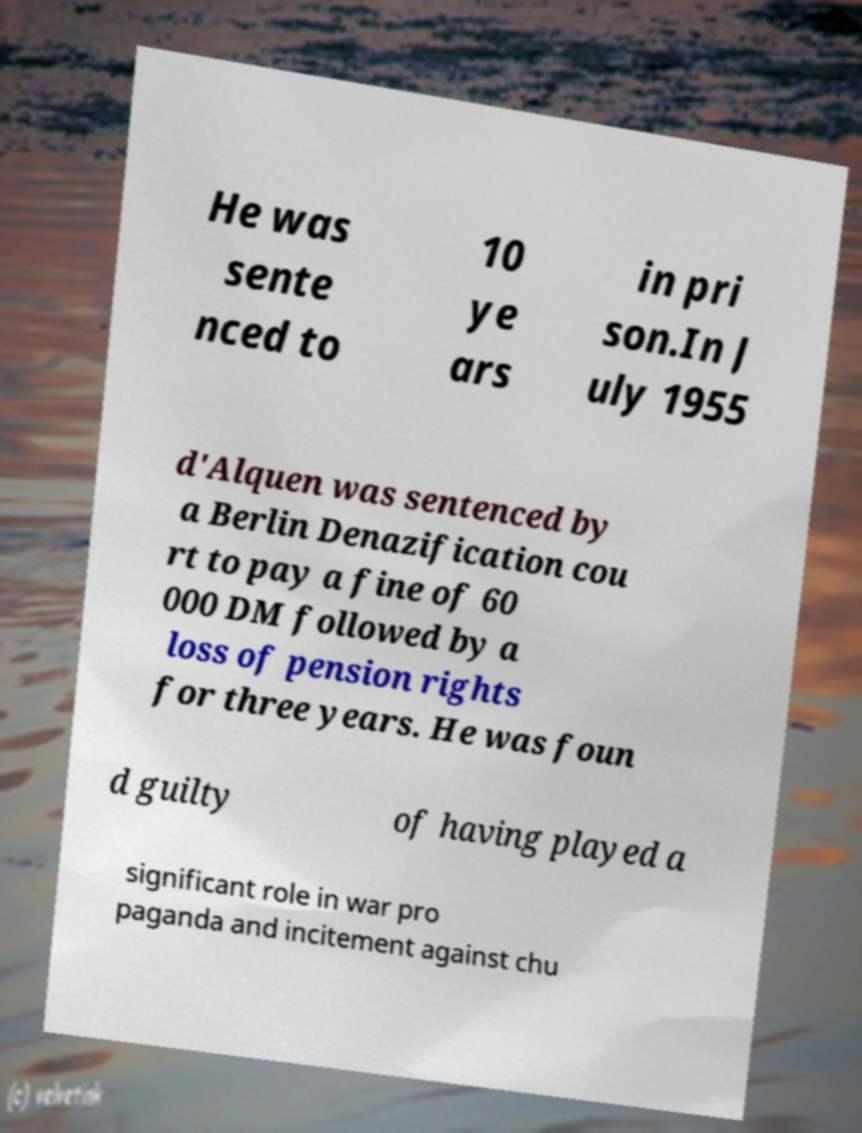I need the written content from this picture converted into text. Can you do that? He was sente nced to 10 ye ars in pri son.In J uly 1955 d'Alquen was sentenced by a Berlin Denazification cou rt to pay a fine of 60 000 DM followed by a loss of pension rights for three years. He was foun d guilty of having played a significant role in war pro paganda and incitement against chu 